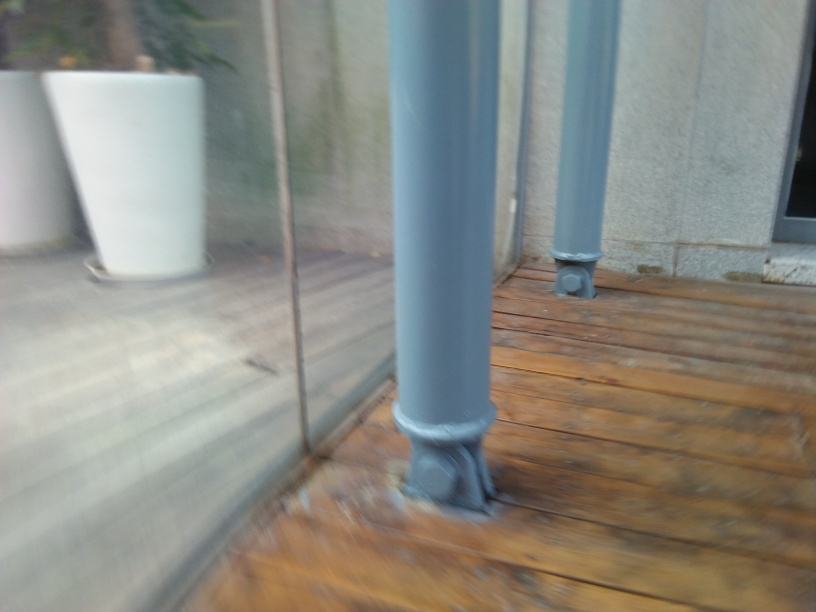Is the ground sharp and clear? The ground in the image is not sharp and clear. It appears blurry, possibly due to camera movement during the exposure, which results in a lack of distinct details on the wooden planks and the surrounding objects. 